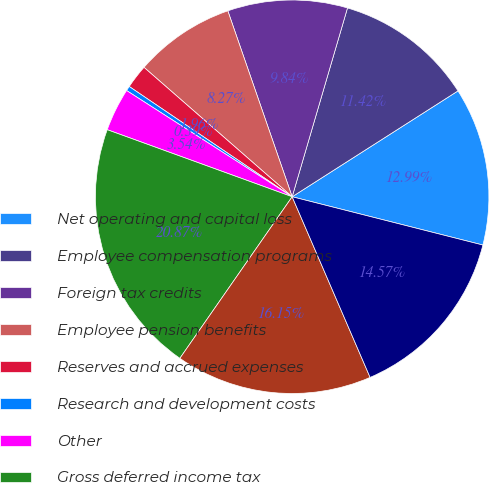Convert chart to OTSL. <chart><loc_0><loc_0><loc_500><loc_500><pie_chart><fcel>Net operating and capital loss<fcel>Employee compensation programs<fcel>Foreign tax credits<fcel>Employee pension benefits<fcel>Reserves and accrued expenses<fcel>Research and development costs<fcel>Other<fcel>Gross deferred income tax<fcel>Valuation allowance<fcel>Total deferred income tax<nl><fcel>12.99%<fcel>11.42%<fcel>9.84%<fcel>8.27%<fcel>1.96%<fcel>0.39%<fcel>3.54%<fcel>20.87%<fcel>16.15%<fcel>14.57%<nl></chart> 